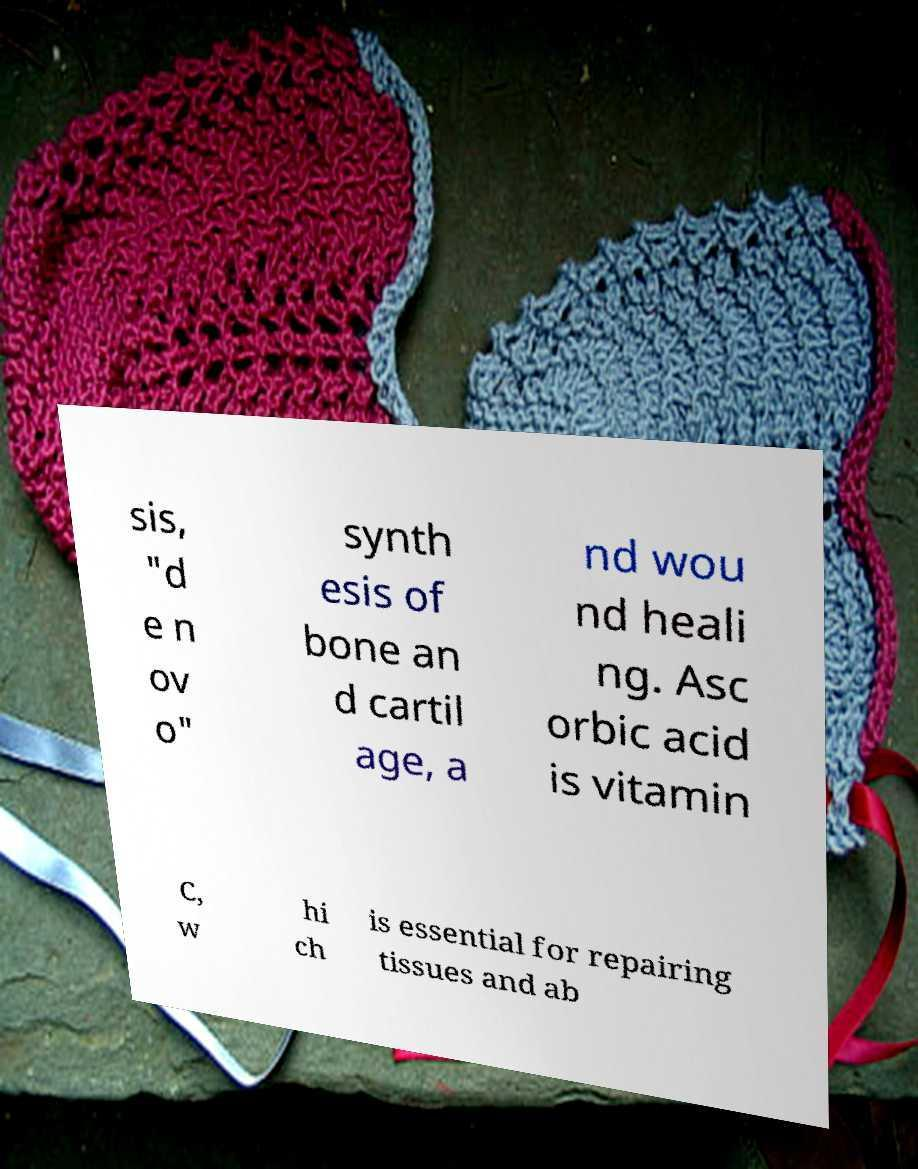For documentation purposes, I need the text within this image transcribed. Could you provide that? sis, "d e n ov o" synth esis of bone an d cartil age, a nd wou nd heali ng. Asc orbic acid is vitamin C, w hi ch is essential for repairing tissues and ab 